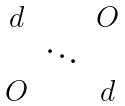Convert formula to latex. <formula><loc_0><loc_0><loc_500><loc_500>\begin{matrix} d & & O \\ & \ddots & \\ O & & d \end{matrix}</formula> 